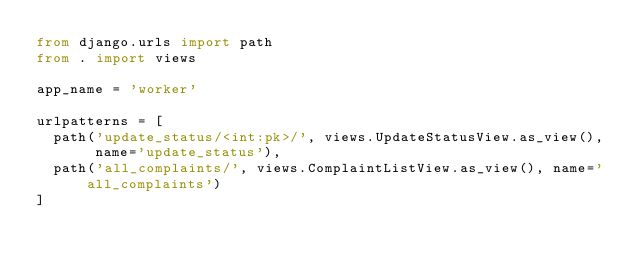<code> <loc_0><loc_0><loc_500><loc_500><_Python_>from django.urls import path
from . import views

app_name = 'worker'

urlpatterns = [
	path('update_status/<int:pk>/', views.UpdateStatusView.as_view(), name='update_status'),
	path('all_complaints/', views.ComplaintListView.as_view(), name='all_complaints')
]</code> 